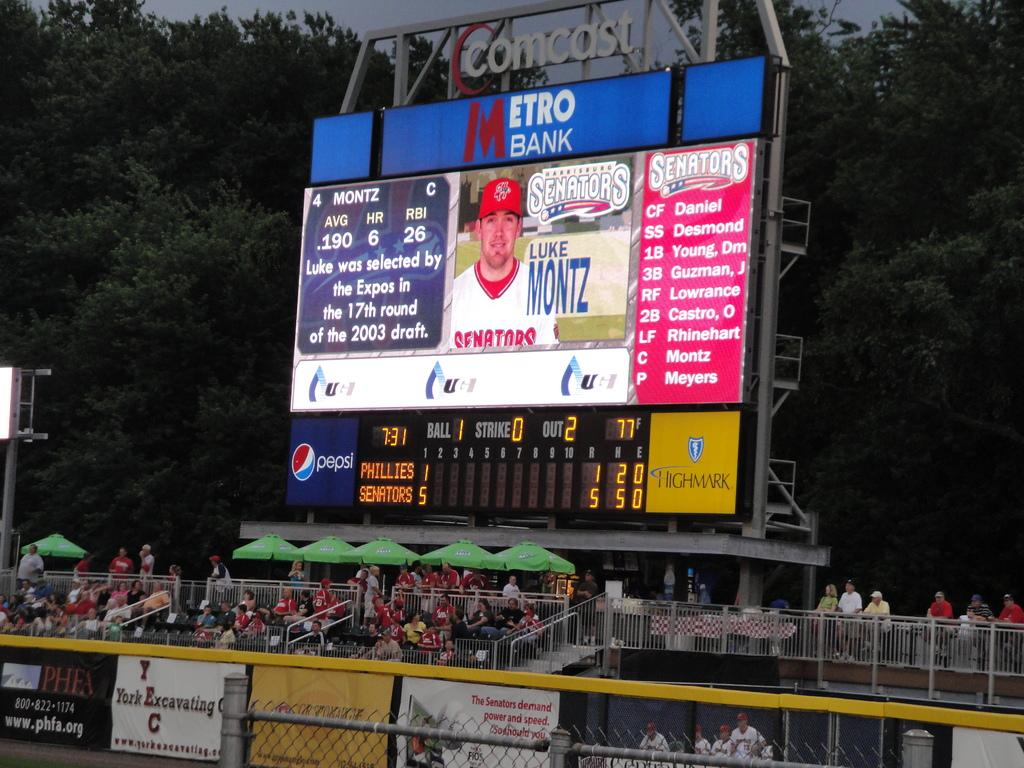<image>
Describe the image concisely. A stadium scoreboard displays company names such as Pepsi, Metro Bank and Comcast. 